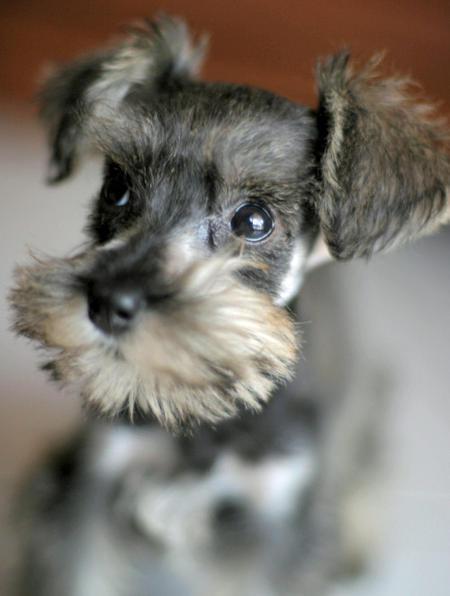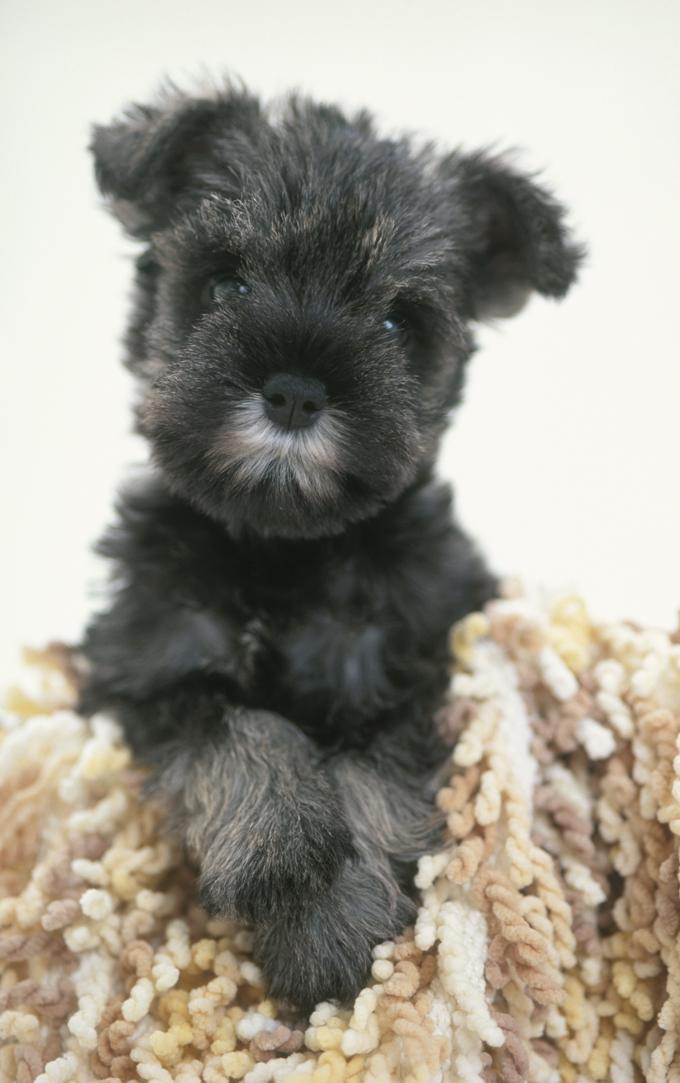The first image is the image on the left, the second image is the image on the right. For the images displayed, is the sentence "Greenery is visible in an image of a schnauzer." factually correct? Answer yes or no. No. 